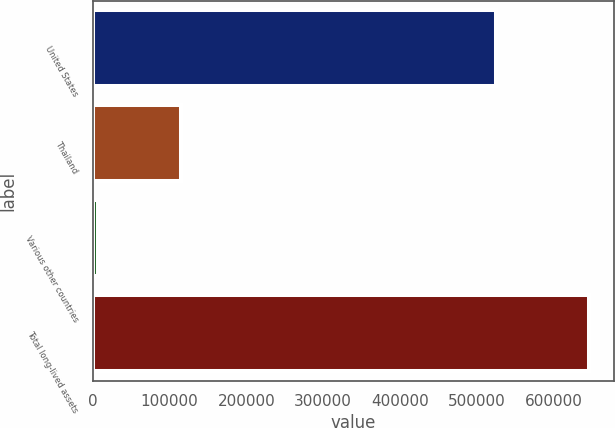<chart> <loc_0><loc_0><loc_500><loc_500><bar_chart><fcel>United States<fcel>Thailand<fcel>Various other countries<fcel>Total long-lived assets<nl><fcel>524950<fcel>114560<fcel>6554<fcel>646064<nl></chart> 